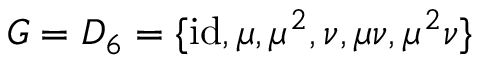<formula> <loc_0><loc_0><loc_500><loc_500>G = D _ { 6 } = \{ { i d } , \mu , \mu ^ { 2 } , \nu , \mu \nu , \mu ^ { 2 } \nu \}</formula> 